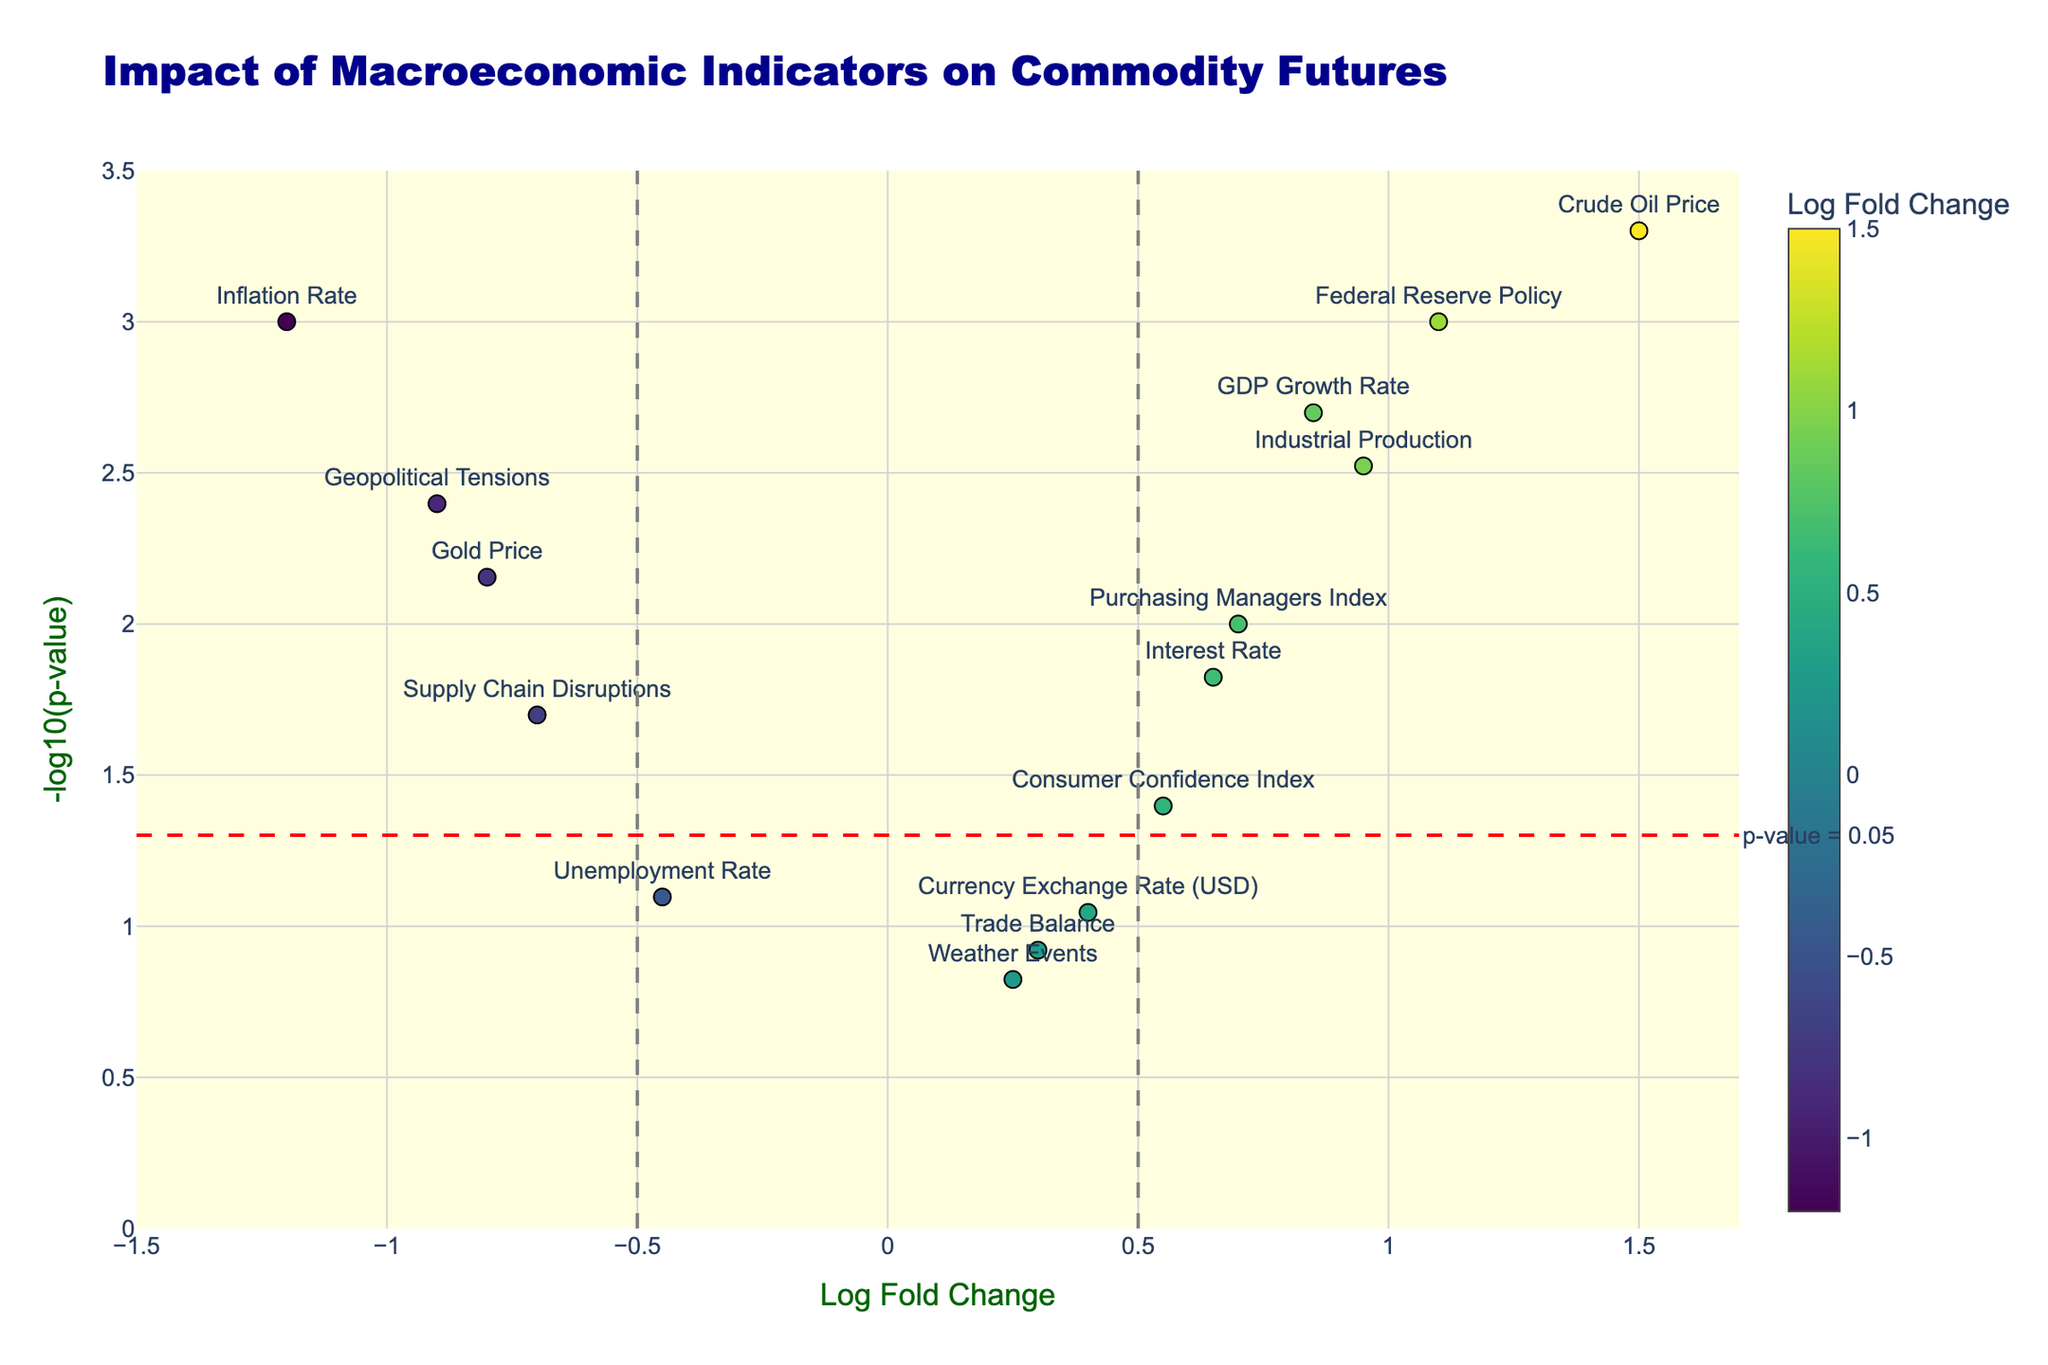Which indicators have a statistically significant impact on commodity futures? Indicators with a p-value less than 0.05 are considered statistically significant. These are visible above the horizontal red dashed line on the y-axis.
Answer: GDP Growth Rate, Inflation Rate, Interest Rate, Industrial Production, Purchasing Managers Index, Crude Oil Price, Gold Price, Federal Reserve Policy, Geopolitical Tensions, Supply Chain Disruptions Which indicator shows the highest positive correlation with commodity futures? The indicator with the highest Log Fold Change value shows the highest positive correlation. This can be identified as the point with the highest x-axis value in the positive half.
Answer: Crude Oil Price Which indicator shows the strongest negative correlation with commodity futures? The indicator with the lowest (most negative) Log Fold Change value shows the strongest negative correlation. This can be identified as the point with the lowest x-axis value in the negative half.
Answer: Inflation Rate What is the significance threshold for the p-values indicated on the plot? The significance threshold is indicated by the horizontal red dashed line on the plot, which corresponds to a p-value of 0.05.
Answer: 0.05 (p-value) How does the Unemployment Rate correlate with commodity futures? The Unemployment Rate has a Log Fold Change of -0.45 and a p-value of 0.08. Since the p-value is greater than 0.05, it indicates a non-significant negative impact on commodity futures.
Answer: Non-significant negative correlation Between GDP Growth Rate and Federal Reserve Policy, which has a higher impact on commodity futures? Compare the Log Fold Change values and p-values of both indicators. GDP Growth Rate has a Log Fold Change of 0.85 and p-value of 0.002, whereas Federal Reserve Policy has a Log Fold Change of 1.1 and p-value of 0.001. Federal Reserve Policy exhibits a higher Log Fold Change, indicating a greater impact.
Answer: Federal Reserve Policy How many indicators show a non-significant impact on commodity futures? Indicators with p-values greater than 0.05 show a non-significant impact. These can be counted as points below the red dashed line on the plot.
Answer: Four indicators (Unemployment Rate, Trade Balance, Currency Exchange Rate (USD), Weather Events) What is the Log Fold Change value for Gold Price? The Log Fold Change value for Gold Price can be located directly on the x-axis labeled point for Gold Price.
Answer: -0.8 Which indicators have a p-value below 0.01? Indicators with p-value below 0.01 are those located above the -log10(0.01) value, which is more than 2 on the y-axis.
Answer: GDP Growth Rate, Inflation Rate, Industrial Production, Crude Oil Price, Federal Reserve Policy, Geopolitical Tensions What is the range of Log Fold Change values displayed in the plot? The x-axis range displayed on the plot for Log Fold Change values runs from around -1.5 to 1.7.
Answer: -1.5 to 1.7 